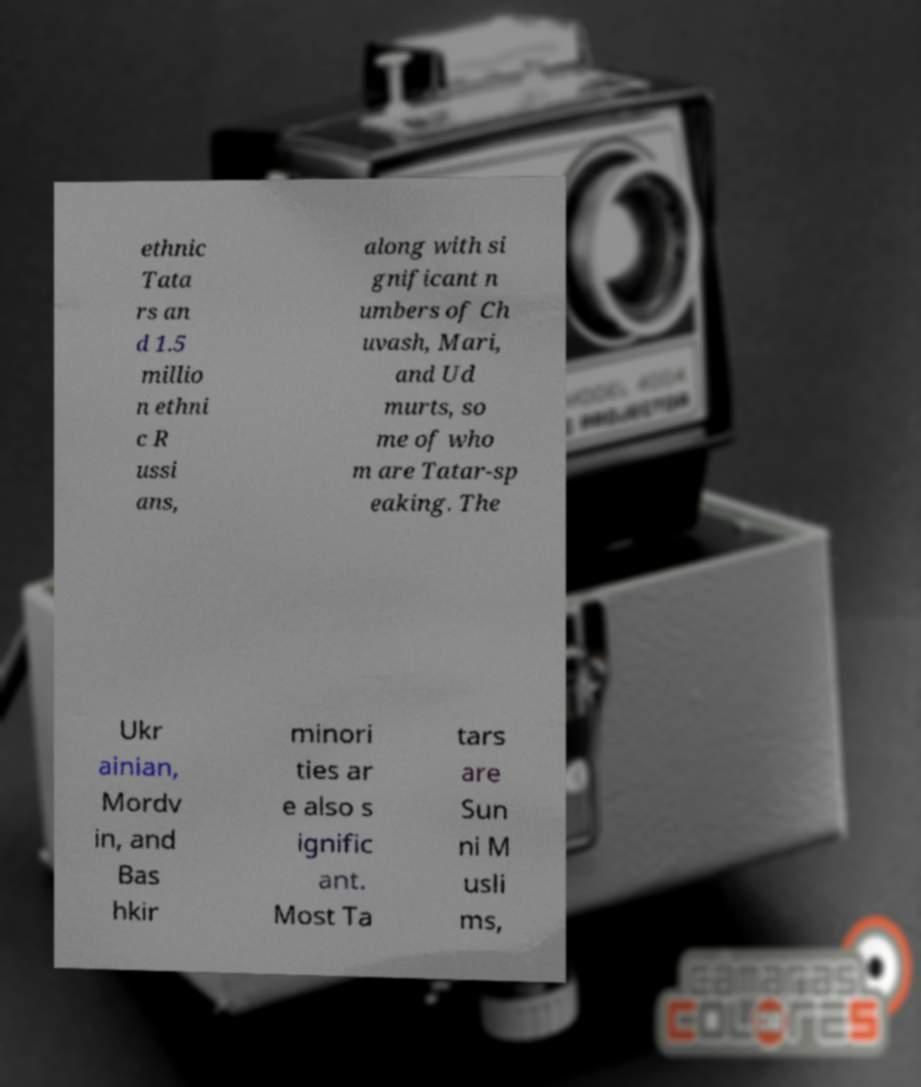Could you extract and type out the text from this image? ethnic Tata rs an d 1.5 millio n ethni c R ussi ans, along with si gnificant n umbers of Ch uvash, Mari, and Ud murts, so me of who m are Tatar-sp eaking. The Ukr ainian, Mordv in, and Bas hkir minori ties ar e also s ignific ant. Most Ta tars are Sun ni M usli ms, 